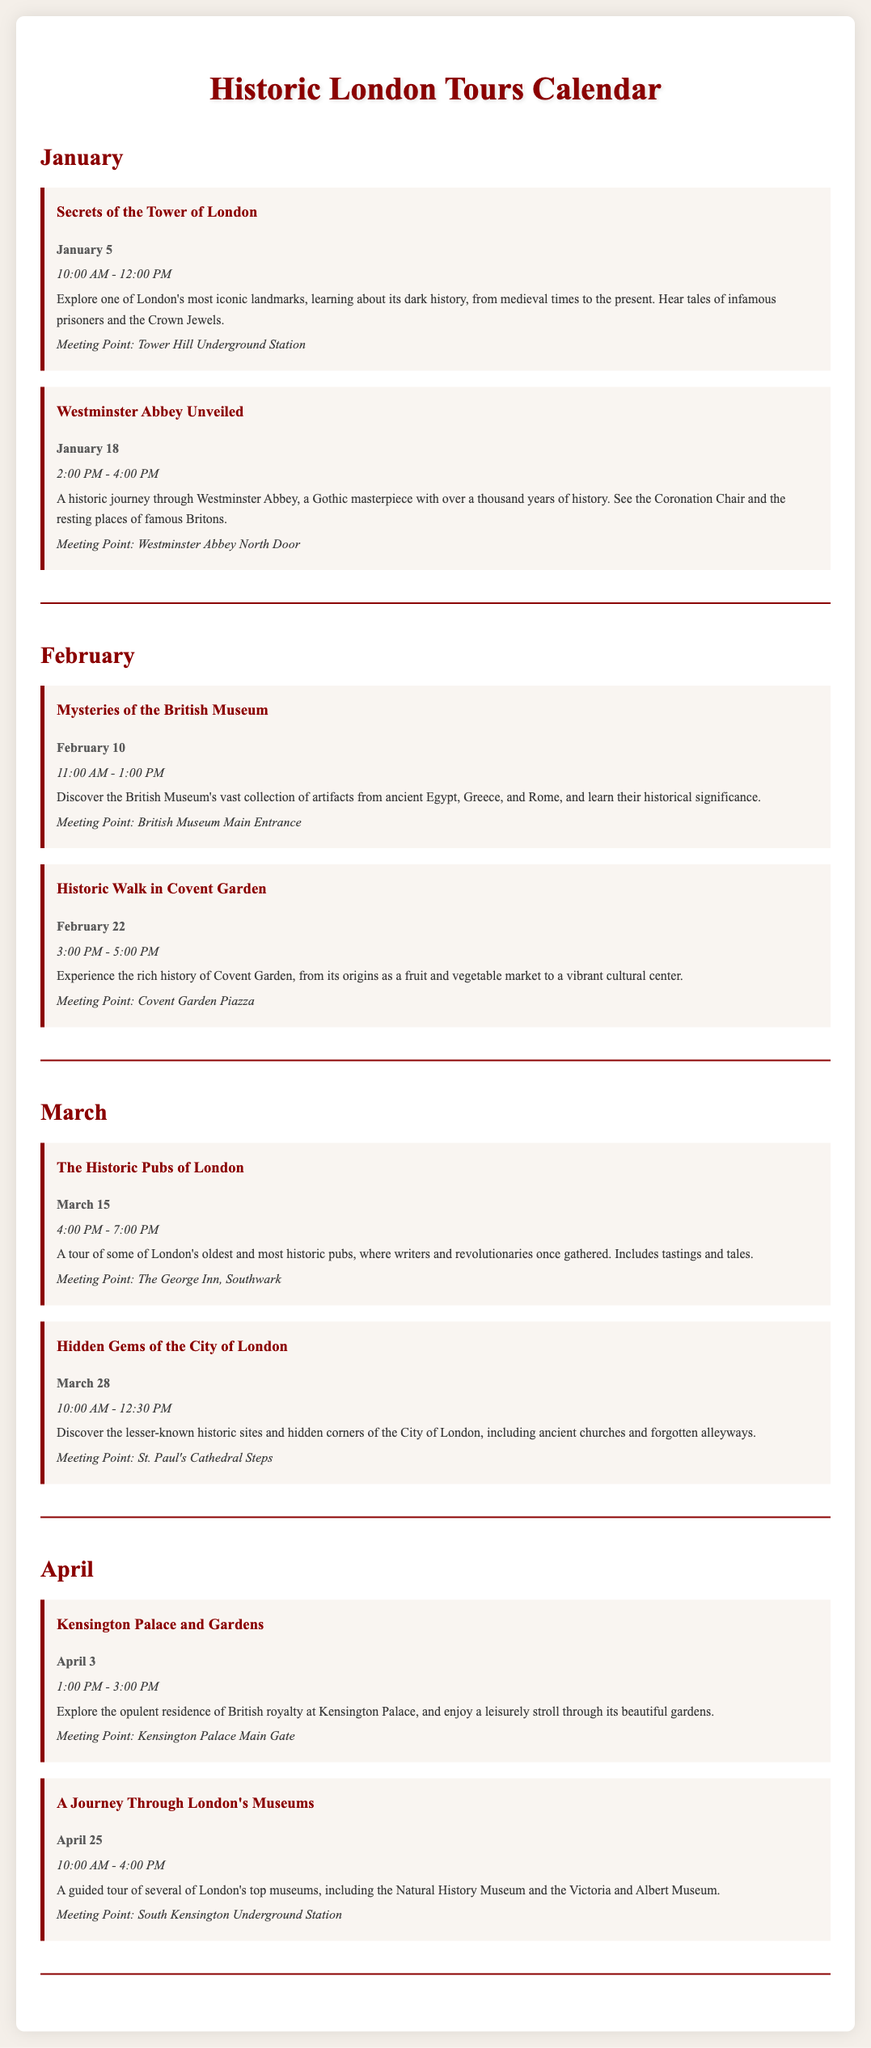What is the title of the first tour in January? The first tour listed in January is titled "Secrets of the Tower of London."
Answer: Secrets of the Tower of London On what date does the "A Journey Through London's Museums" tour take place? This tour is scheduled for April 25.
Answer: April 25 What time does the "Westminster Abbey Unveiled" tour start? The "Westminster Abbey Unveiled" tour starts at 2:00 PM.
Answer: 2:00 PM How many tours are offered in March? There are two tours offered in March.
Answer: 2 What is the meeting point for the "Historic Walk in Covent Garden"? The meeting point is at Covent Garden Piazza.
Answer: Covent Garden Piazza Which month features the "Mysteries of the British Museum" tour? This tour is featured in February.
Answer: February What is the duration of the "Secrets of the Tower of London" tour? The duration of this tour is 2 hours, from 10:00 AM to 12:00 PM.
Answer: 2 hours What type of locations are included in the "Hidden Gems of the City of London" tour? The tour includes lesser-known historic sites and hidden corners of the City of London.
Answer: Lesser-known historic sites Which tour includes tastings? The "The Historic Pubs of London" tour includes tastings.
Answer: The Historic Pubs of London 